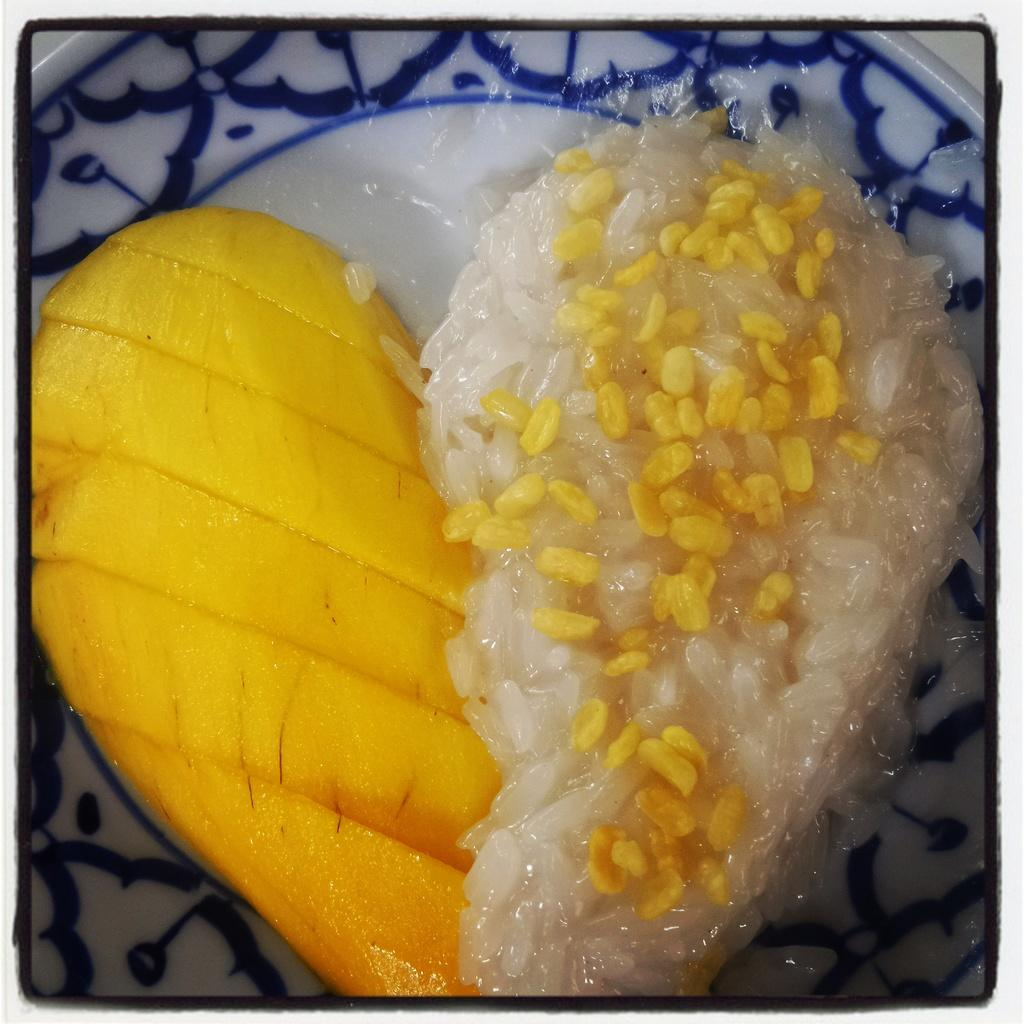What is on the plate that is visible in the image? The plate contains food. How is the food arranged on the plate? The food is arranged in a heart shape. How many plates are visible in the image? There are multiple plates in the image. Is there any indication that the image might not be a true representation of the scene? The image might be edited, so it may not be an accurate representation of the scene. What type of creature can be seen riding a train in the image? There is no train or creature present in the image; it features a plate with food arranged in a heart shape. 